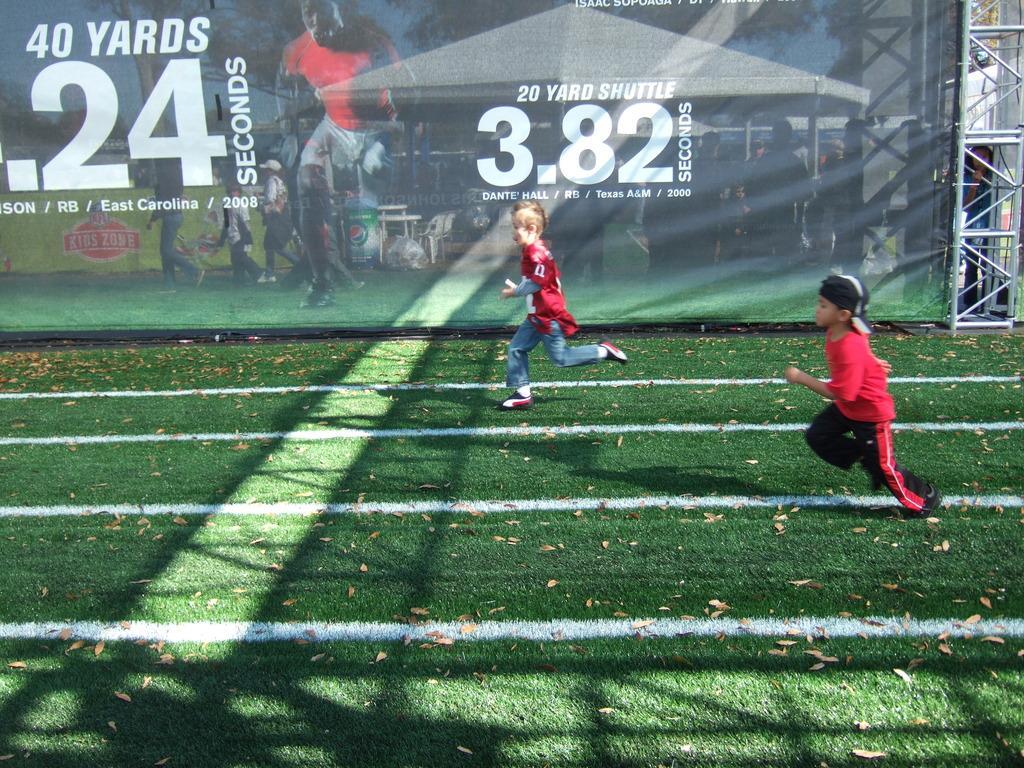Describe this image in one or two sentences. This is a playing ground. Here I can see two boys are running on the ground towards the left side. In the background, I can see a banner on which I can see some text and images of persons. Beside the banner there is a metal stand. 